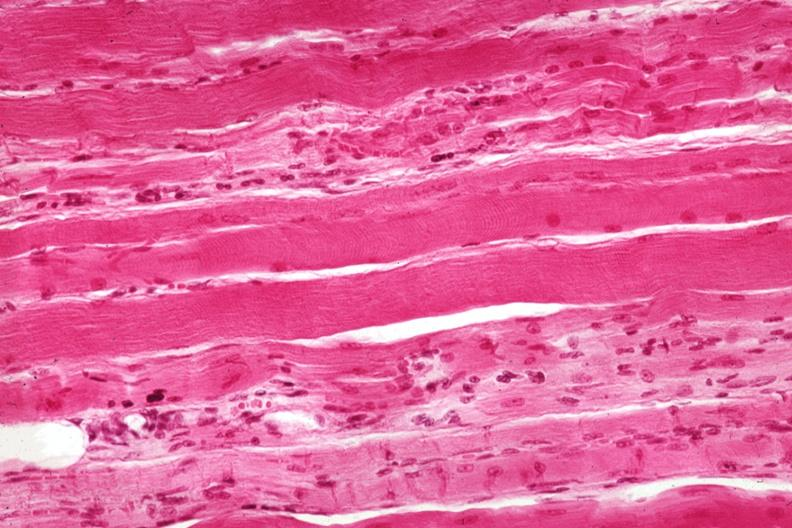does esophagus show good depiction focal fiber atrophy?
Answer the question using a single word or phrase. No 